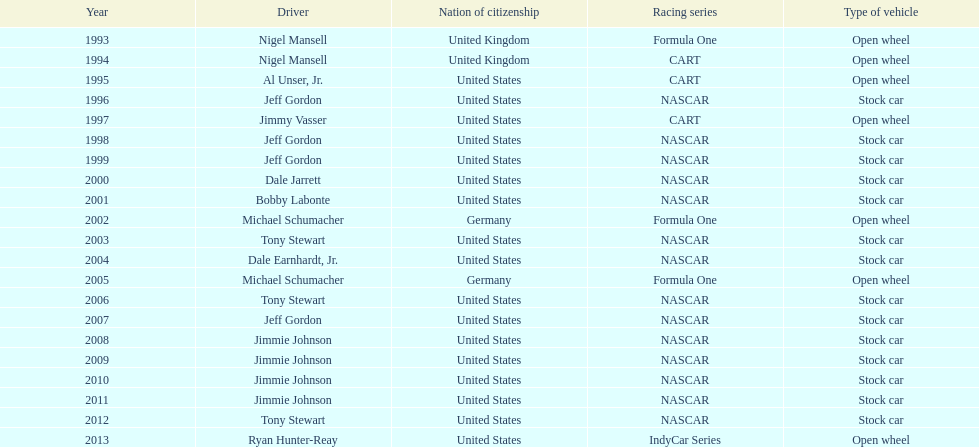Which driver claimed espy awards titles with an 11-year difference between their wins? Jeff Gordon. 